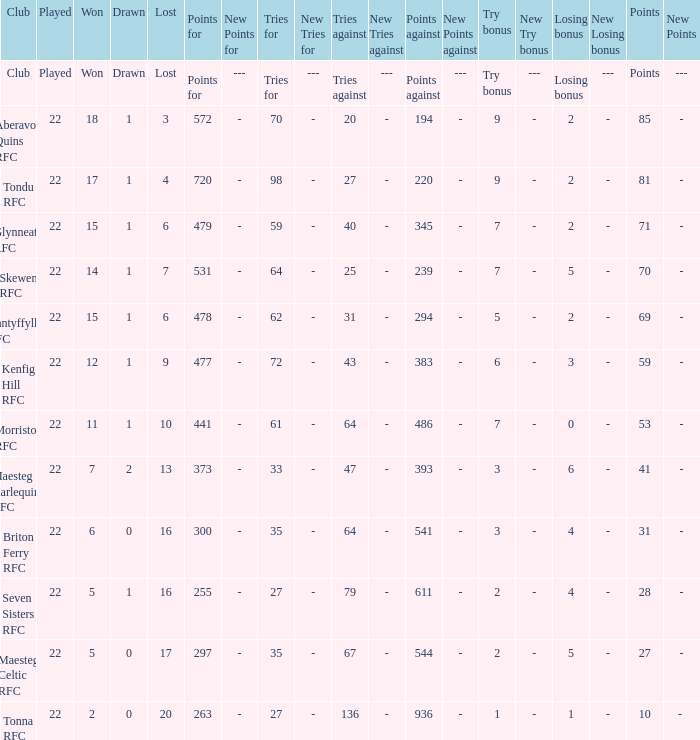Would you mind parsing the complete table? {'header': ['Club', 'Played', 'Won', 'Drawn', 'Lost', 'Points for', 'New Points for', 'Tries for', 'New Tries for', 'Tries against', 'New Tries against', 'Points against', 'New Points against', 'Try bonus', 'New Try bonus', 'Losing bonus', 'New Losing bonus', 'Points', 'New Points'], 'rows': [['Club', 'Played', 'Won', 'Drawn', 'Lost', 'Points for', '---', 'Tries for', '---', 'Tries against', '---', 'Points against', '---', 'Try bonus', '---', 'Losing bonus', '---', 'Points', '---'], ['Aberavon Quins RFC', '22', '18', '1', '3', '572', '-', '70', '-', '20', '-', '194', '-', '9', '-', '2', '-', '85', '-'], ['Tondu RFC', '22', '17', '1', '4', '720', '-', '98', '-', '27', '-', '220', '-', '9', '-', '2', '-', '81', '-'], ['Glynneath RFC', '22', '15', '1', '6', '479', '-', '59', '-', '40', '-', '345', '-', '7', '-', '2', '-', '71', '-'], ['Skewen RFC', '22', '14', '1', '7', '531', '-', '64', '-', '25', '-', '239', '-', '7', '-', '5', '-', '70', '-'], ['Nantyffyllon RFC', '22', '15', '1', '6', '478', '-', '62', '-', '31', '-', '294', '-', '5', '-', '2', '-', '69', '-'], ['Kenfig Hill RFC', '22', '12', '1', '9', '477', '-', '72', '-', '43', '-', '383', '-', '6', '-', '3', '-', '59', '-'], ['Morriston RFC', '22', '11', '1', '10', '441', '-', '61', '-', '64', '-', '486', '-', '7', '-', '0', '-', '53', '-'], ['Maesteg Harlequins RFC', '22', '7', '2', '13', '373', '-', '33', '-', '47', '-', '393', '-', '3', '-', '6', '-', '41', '-'], ['Briton Ferry RFC', '22', '6', '0', '16', '300', '-', '35', '-', '64', '-', '541', '-', '3', '-', '4', '-', '31', '-'], ['Seven Sisters RFC', '22', '5', '1', '16', '255', '-', '27', '-', '79', '-', '611', '-', '2', '-', '4', '-', '28', '-'], ['Maesteg Celtic RFC', '22', '5', '0', '17', '297', '-', '35', '-', '67', '-', '544', '-', '2', '-', '5', '-', '27', '-'], ['Tonna RFC', '22', '2', '0', '20', '263', '-', '27', '-', '136', '-', '936', '-', '1', '-', '1', '-', '10', '- ']]} When the lost column has the value "lost," what is the corresponding value in the points column? Points. 